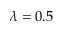<formula> <loc_0><loc_0><loc_500><loc_500>\lambda = 0 . 5</formula> 